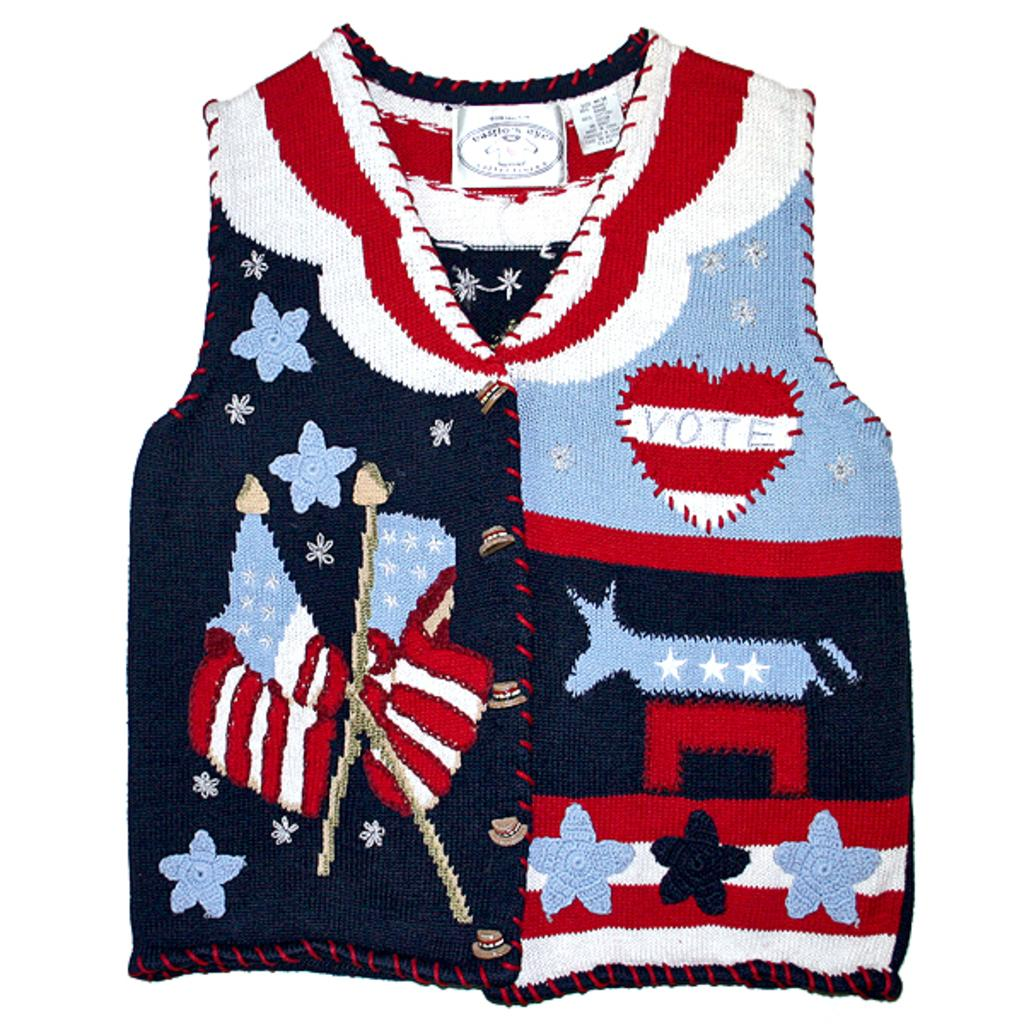Provide a one-sentence caption for the provided image. Sweater vest that contains designs on it with a heart to vote. 